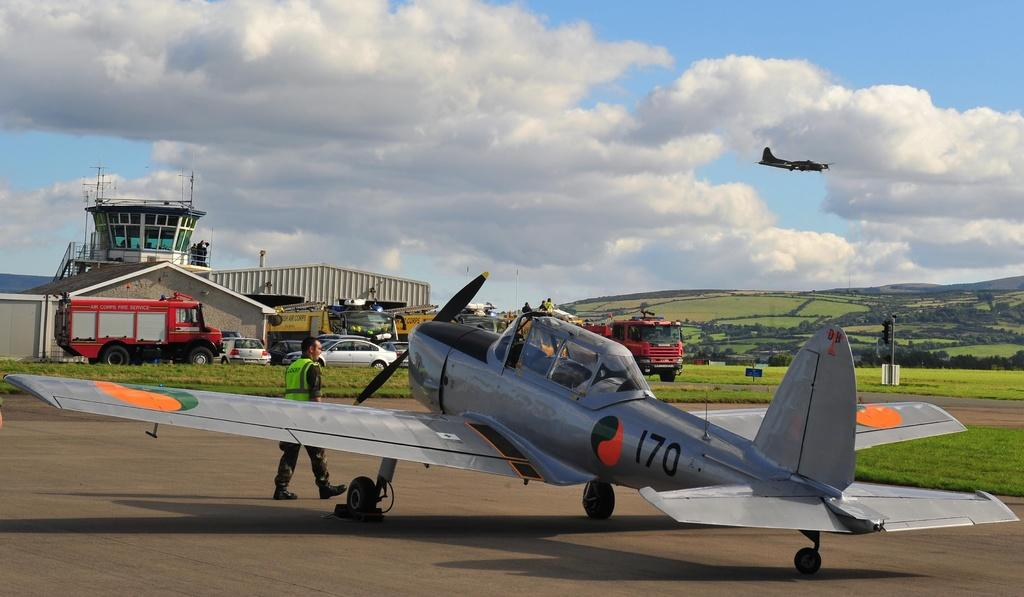<image>
Describe the image concisely. An airplane number 170 sits on a runway as a man walks in front of it. 